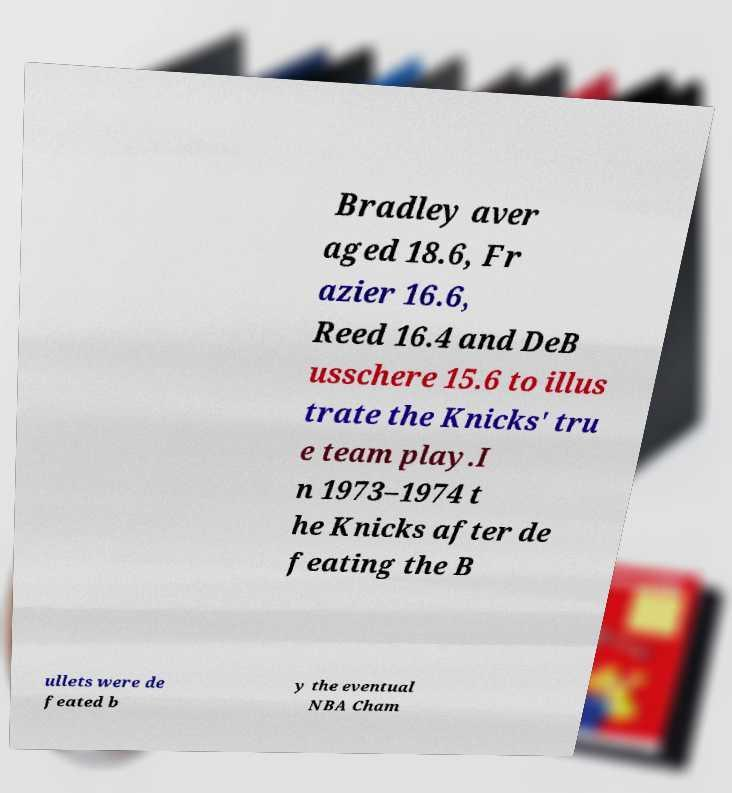I need the written content from this picture converted into text. Can you do that? Bradley aver aged 18.6, Fr azier 16.6, Reed 16.4 and DeB usschere 15.6 to illus trate the Knicks' tru e team play.I n 1973–1974 t he Knicks after de feating the B ullets were de feated b y the eventual NBA Cham 